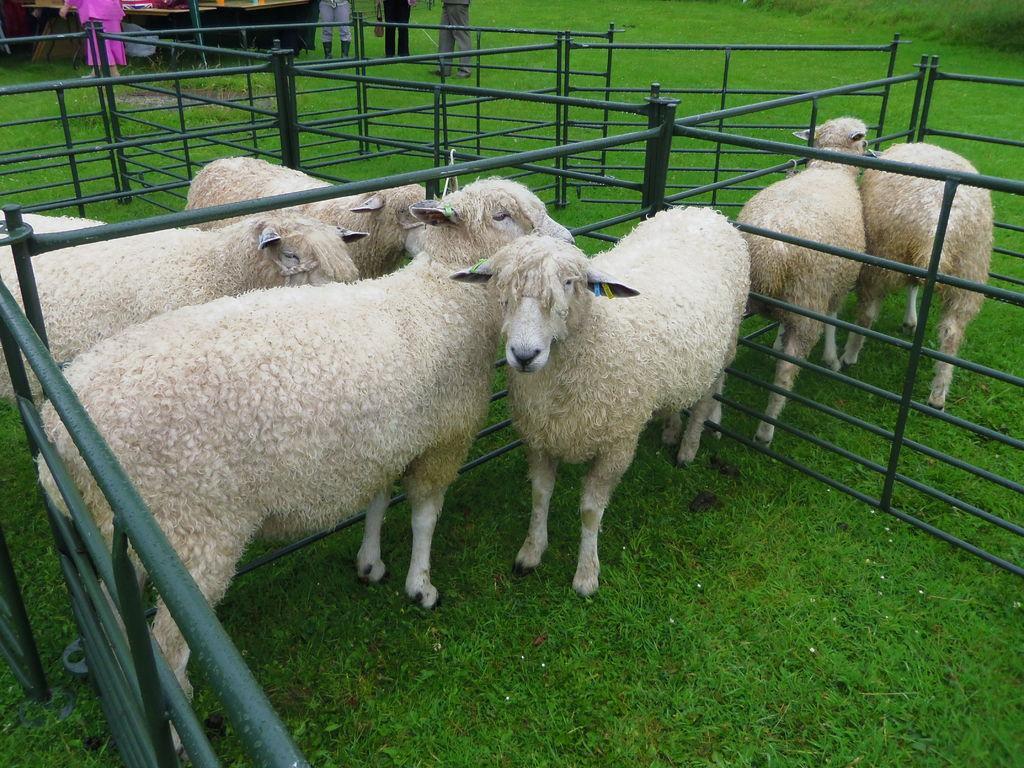Please provide a concise description of this image. In this image image in the center there are animals and there is a fence, at the bottom there is grass. And in the background there are some people standing and it seems that there might be a vehicle. 